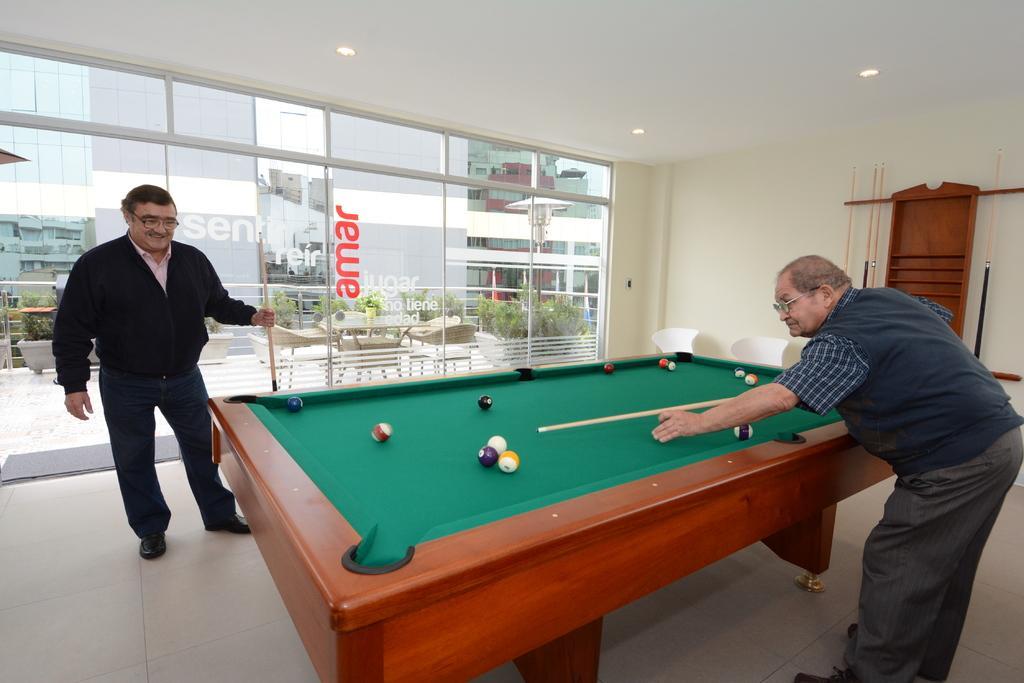How would you summarize this image in a sentence or two? in this picture we can see a man playing snookers, here is the ball and stick, and to opposite him a man is standing on the floor and smiling, and holding a stick in his hand, and at back there is glass door, and there are flower pots, and chairs. 